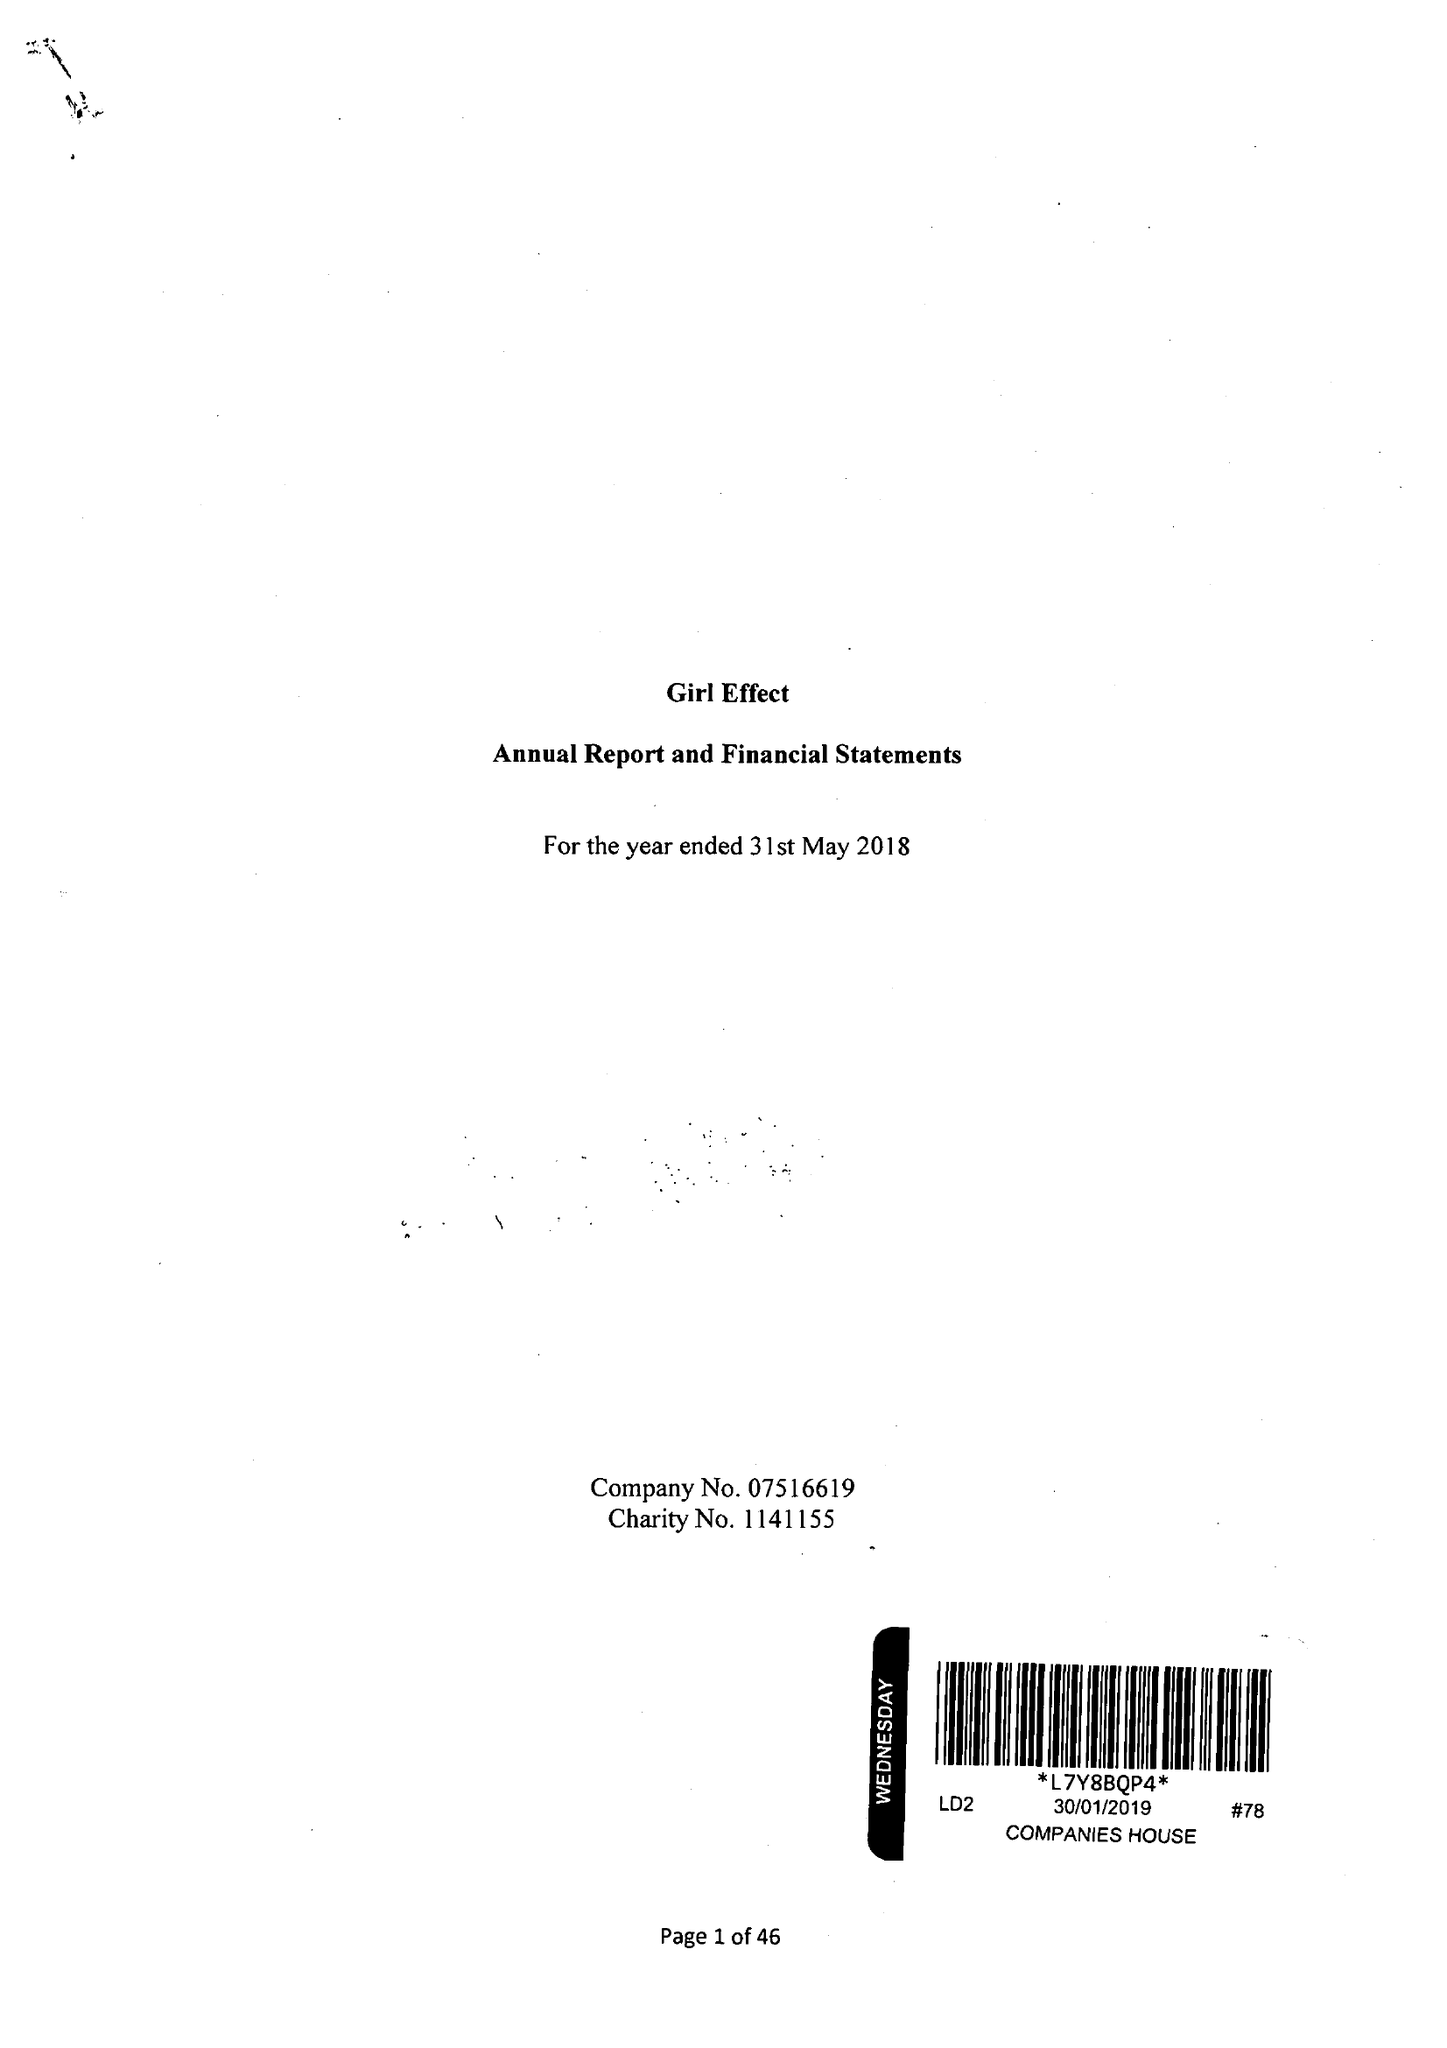What is the value for the address__postcode?
Answer the question using a single word or phrase. W1F 0DJ 